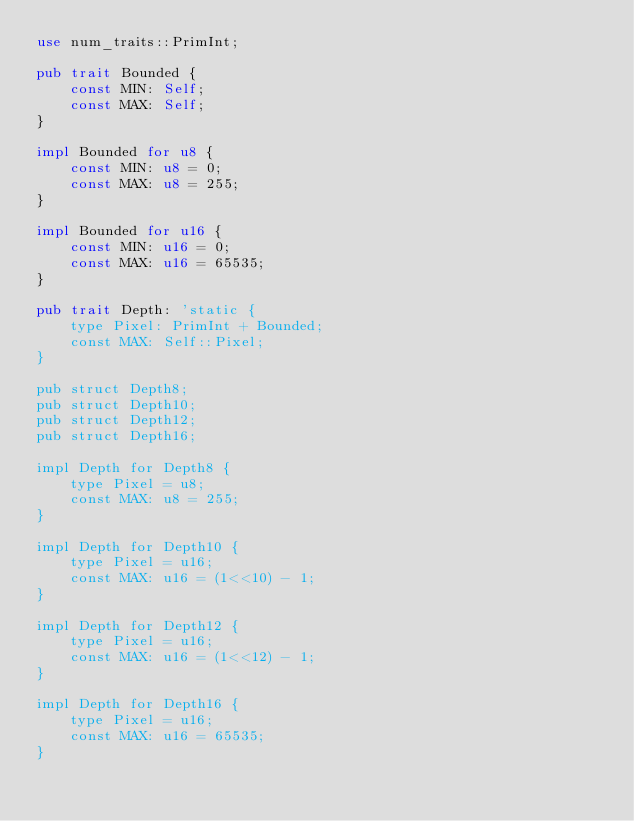Convert code to text. <code><loc_0><loc_0><loc_500><loc_500><_Rust_>use num_traits::PrimInt;

pub trait Bounded {
    const MIN: Self;
    const MAX: Self;
}

impl Bounded for u8 {
    const MIN: u8 = 0;
    const MAX: u8 = 255;
}

impl Bounded for u16 {
    const MIN: u16 = 0;
    const MAX: u16 = 65535;
}

pub trait Depth: 'static {
    type Pixel: PrimInt + Bounded;
    const MAX: Self::Pixel;
}

pub struct Depth8;
pub struct Depth10;
pub struct Depth12;
pub struct Depth16;

impl Depth for Depth8 {
    type Pixel = u8;
    const MAX: u8 = 255;
}

impl Depth for Depth10 {
    type Pixel = u16;
    const MAX: u16 = (1<<10) - 1;
}

impl Depth for Depth12 {
    type Pixel = u16;
    const MAX: u16 = (1<<12) - 1;
}

impl Depth for Depth16 {
    type Pixel = u16;
    const MAX: u16 = 65535;
}
</code> 